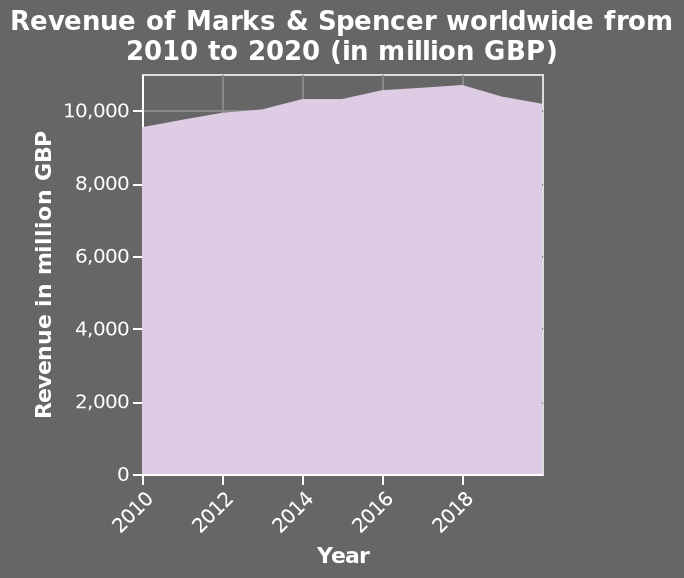<image>
What is the time period covered by the chart? The chart covers the time period from 2010 to 2020. 